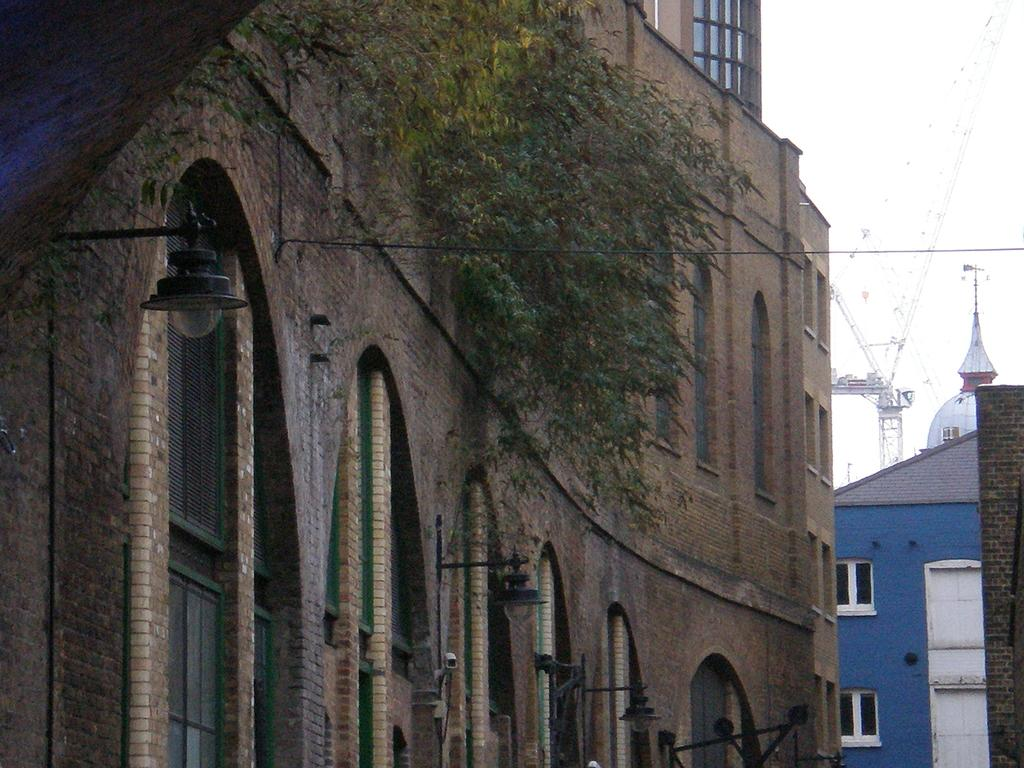What type of structures can be seen in the image? There are buildings in the image. What else is present in the image besides the buildings? There are wires and a tree in the image. What type of waves can be seen crashing against the buildings in the image? There are no waves present in the image; it features buildings, wires, and a tree. Can you describe the partner of the tree in the image? There is no partner for the tree in the image, as it is the only tree visible. 